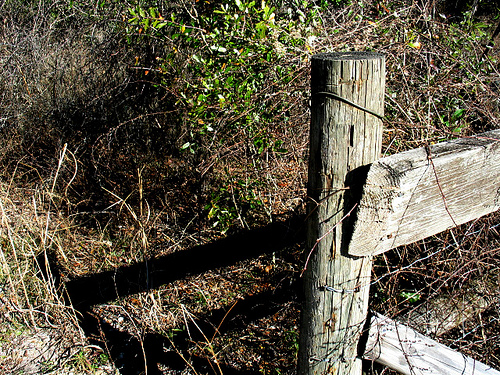<image>
Is the fence behind the plant? No. The fence is not behind the plant. From this viewpoint, the fence appears to be positioned elsewhere in the scene. 